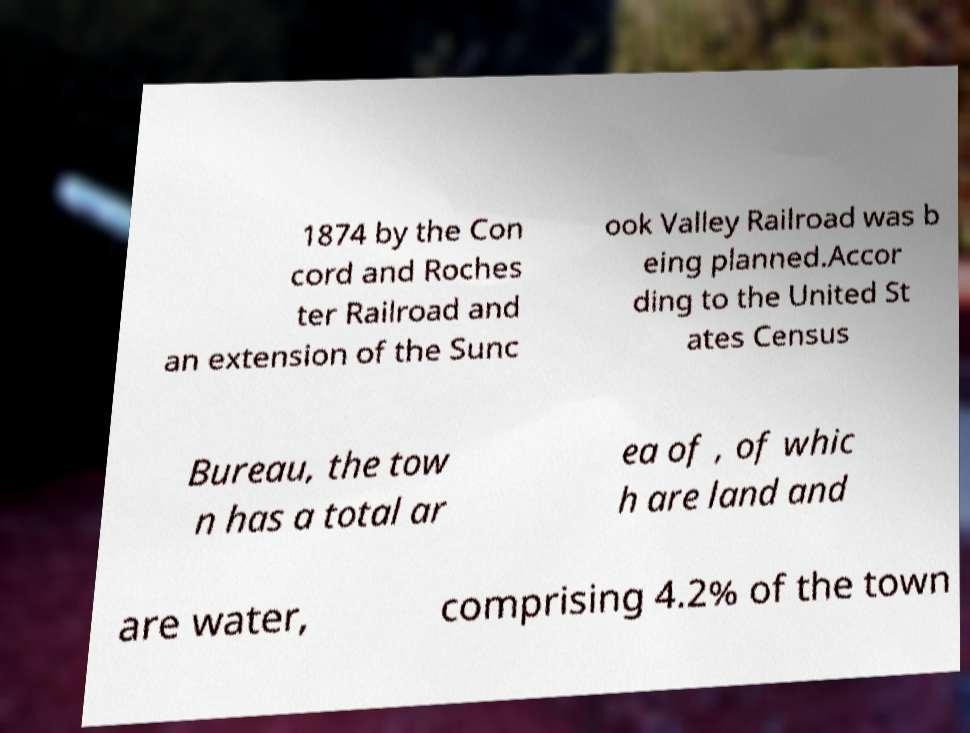Could you extract and type out the text from this image? 1874 by the Con cord and Roches ter Railroad and an extension of the Sunc ook Valley Railroad was b eing planned.Accor ding to the United St ates Census Bureau, the tow n has a total ar ea of , of whic h are land and are water, comprising 4.2% of the town 